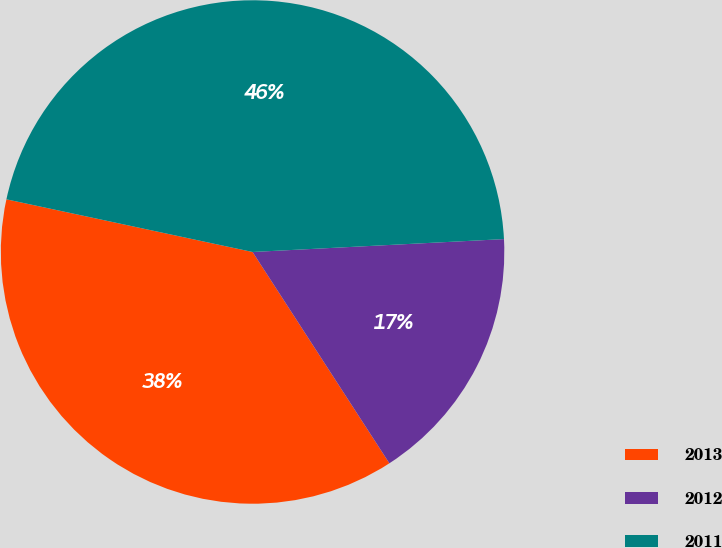Convert chart to OTSL. <chart><loc_0><loc_0><loc_500><loc_500><pie_chart><fcel>2013<fcel>2012<fcel>2011<nl><fcel>37.5%<fcel>16.67%<fcel>45.83%<nl></chart> 